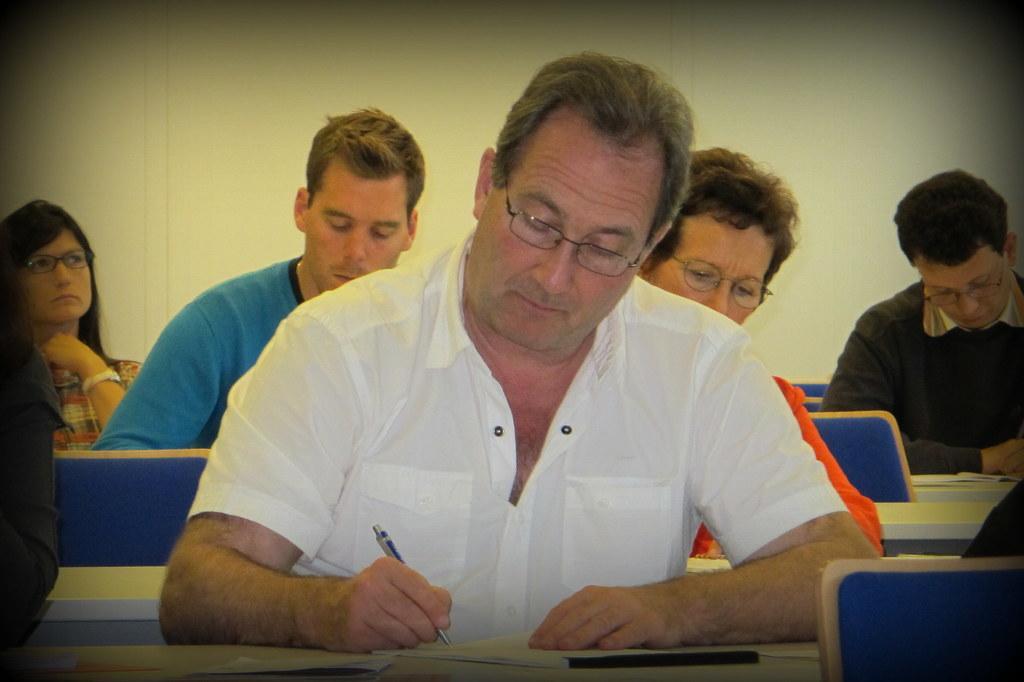Describe this image in one or two sentences. In the image there is a man in the foreground, he sitting and writing something on a book and behind him there are few other people, they are also sitting and in the background there is a wall. 